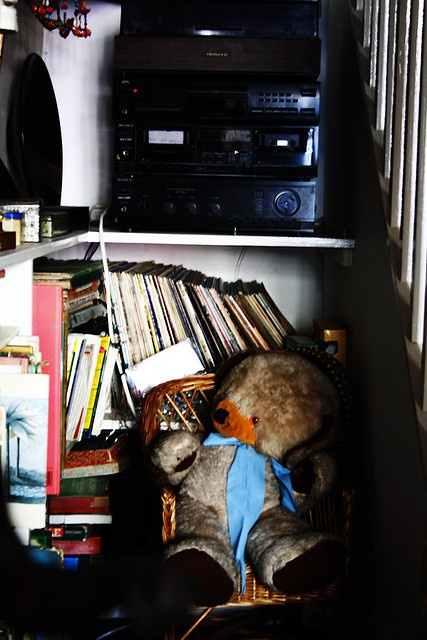Describe the objects in this image and their specific colors. I can see teddy bear in lightgray, black, gray, and maroon tones, book in lightgray, black, ivory, darkgray, and gray tones, book in lightgray, white, teal, lightblue, and blue tones, book in lightgray, lightpink, salmon, and white tones, and chair in lightgray, black, maroon, brown, and gray tones in this image. 